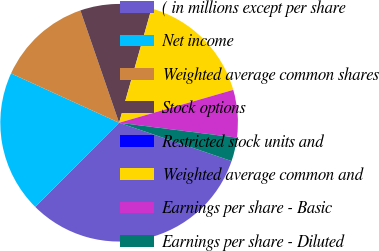<chart> <loc_0><loc_0><loc_500><loc_500><pie_chart><fcel>( in millions except per share<fcel>Net income<fcel>Weighted average common shares<fcel>Stock options<fcel>Restricted stock units and<fcel>Weighted average common and<fcel>Earnings per share - Basic<fcel>Earnings per share - Diluted<nl><fcel>32.24%<fcel>19.35%<fcel>12.9%<fcel>9.68%<fcel>0.01%<fcel>16.13%<fcel>6.46%<fcel>3.23%<nl></chart> 